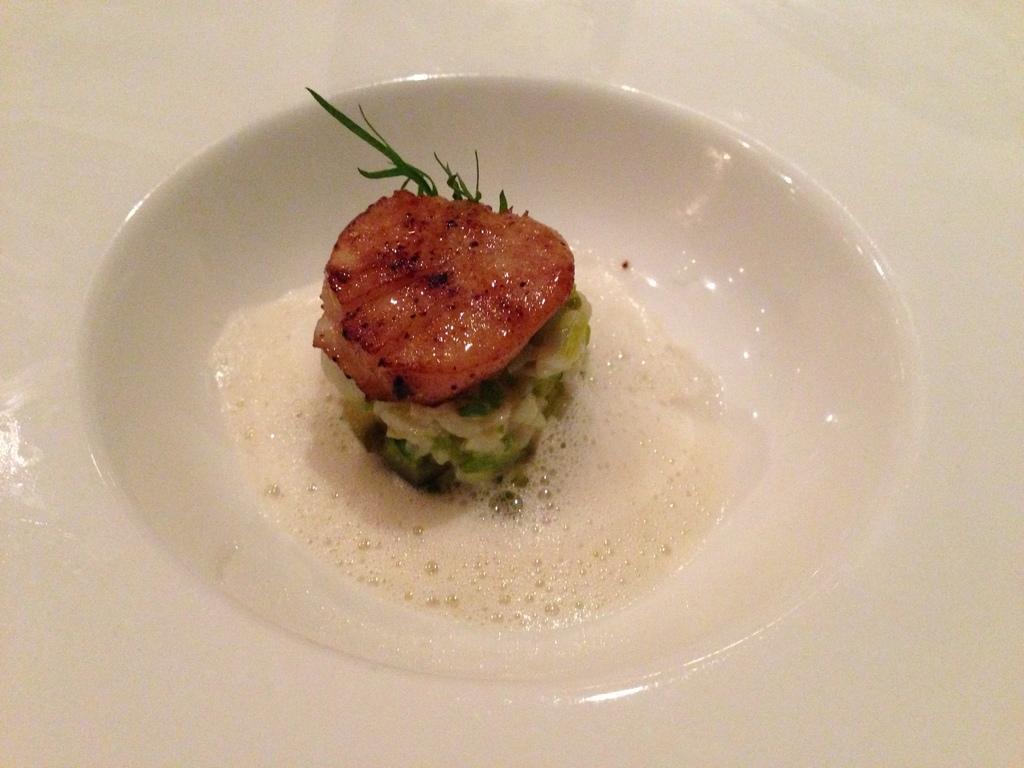Can you describe this image briefly? In this picture I can see a plate in front, which is of white in color and I see the food which is of red, white and green in color and I see that this plate is on the white color surface. 